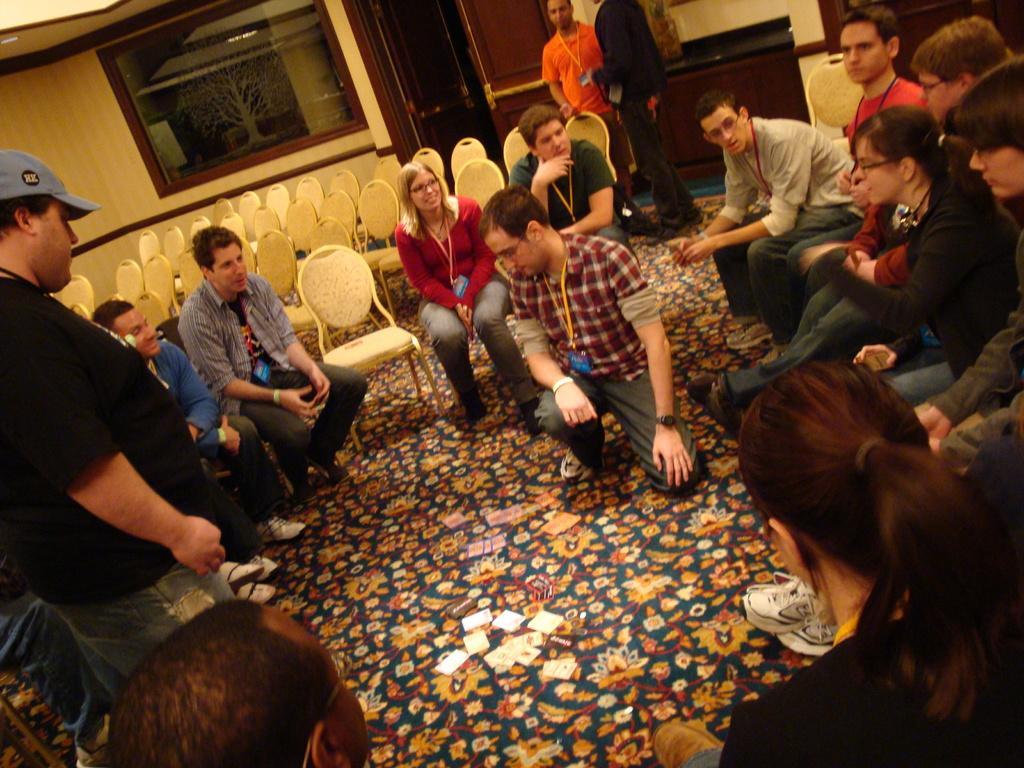Could you give a brief overview of what you see in this image? In this picture I can see number of people in front and I see that most of them are sitting on chairs and rest of them are standing and I see few empty chairs in the background and I see the wall, doors and a window glass. 